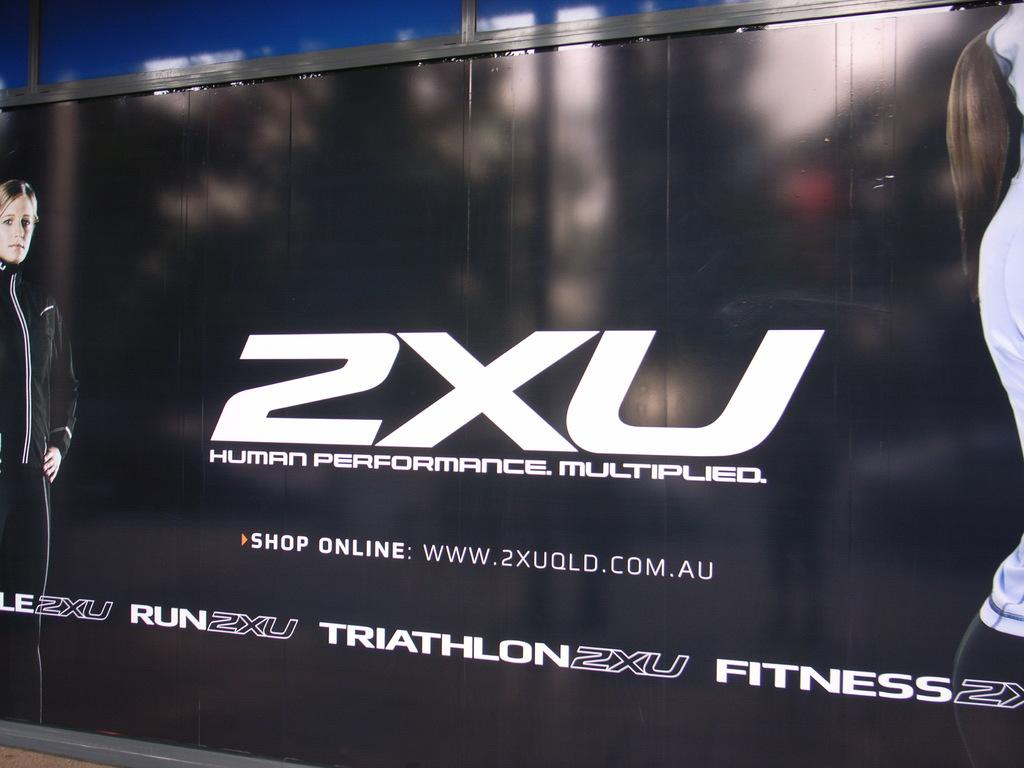Provide a one-sentence caption for the provided image. An online fitness ad is displayed that links to their website. 